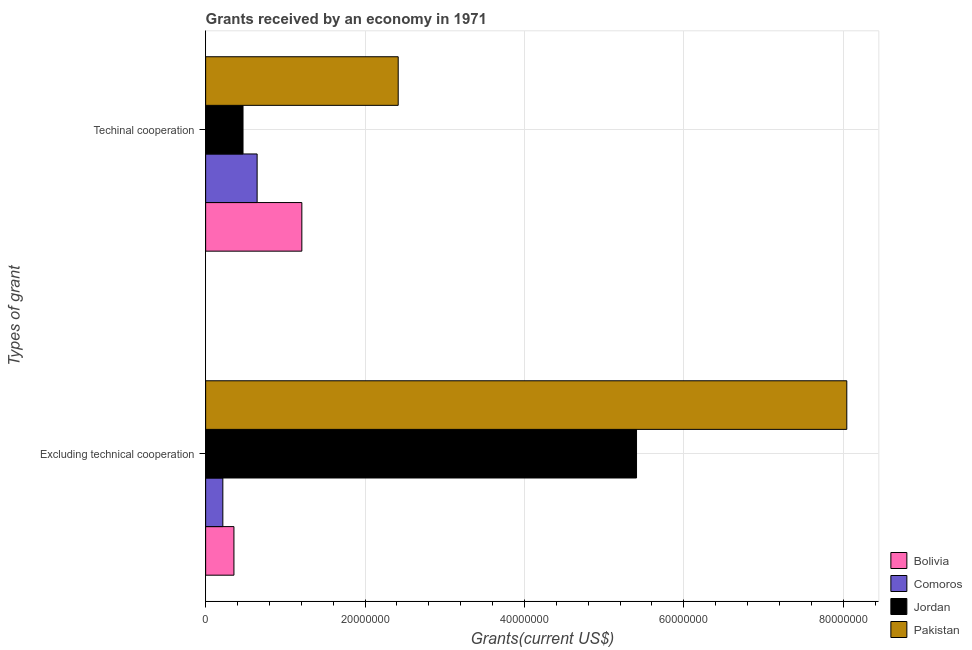How many bars are there on the 1st tick from the top?
Provide a succinct answer. 4. What is the label of the 1st group of bars from the top?
Provide a succinct answer. Techinal cooperation. What is the amount of grants received(including technical cooperation) in Comoros?
Provide a succinct answer. 6.46e+06. Across all countries, what is the maximum amount of grants received(including technical cooperation)?
Offer a terse response. 2.42e+07. Across all countries, what is the minimum amount of grants received(excluding technical cooperation)?
Provide a short and direct response. 2.16e+06. In which country was the amount of grants received(excluding technical cooperation) maximum?
Offer a very short reply. Pakistan. In which country was the amount of grants received(including technical cooperation) minimum?
Give a very brief answer. Jordan. What is the total amount of grants received(including technical cooperation) in the graph?
Offer a terse response. 4.74e+07. What is the difference between the amount of grants received(including technical cooperation) in Pakistan and that in Jordan?
Give a very brief answer. 1.95e+07. What is the difference between the amount of grants received(excluding technical cooperation) in Bolivia and the amount of grants received(including technical cooperation) in Comoros?
Offer a terse response. -2.91e+06. What is the average amount of grants received(including technical cooperation) per country?
Provide a short and direct response. 1.18e+07. What is the difference between the amount of grants received(excluding technical cooperation) and amount of grants received(including technical cooperation) in Jordan?
Your response must be concise. 4.94e+07. In how many countries, is the amount of grants received(excluding technical cooperation) greater than 68000000 US$?
Provide a succinct answer. 1. What is the ratio of the amount of grants received(including technical cooperation) in Pakistan to that in Jordan?
Provide a succinct answer. 5.15. Is the amount of grants received(including technical cooperation) in Comoros less than that in Pakistan?
Offer a very short reply. Yes. What does the 3rd bar from the top in Excluding technical cooperation represents?
Make the answer very short. Comoros. What does the 3rd bar from the bottom in Excluding technical cooperation represents?
Your answer should be compact. Jordan. How many bars are there?
Give a very brief answer. 8. What is the difference between two consecutive major ticks on the X-axis?
Ensure brevity in your answer.  2.00e+07. Where does the legend appear in the graph?
Your answer should be very brief. Bottom right. What is the title of the graph?
Your answer should be compact. Grants received by an economy in 1971. Does "Vietnam" appear as one of the legend labels in the graph?
Ensure brevity in your answer.  No. What is the label or title of the X-axis?
Offer a terse response. Grants(current US$). What is the label or title of the Y-axis?
Provide a succinct answer. Types of grant. What is the Grants(current US$) in Bolivia in Excluding technical cooperation?
Your answer should be compact. 3.55e+06. What is the Grants(current US$) in Comoros in Excluding technical cooperation?
Keep it short and to the point. 2.16e+06. What is the Grants(current US$) in Jordan in Excluding technical cooperation?
Ensure brevity in your answer.  5.41e+07. What is the Grants(current US$) of Pakistan in Excluding technical cooperation?
Provide a succinct answer. 8.04e+07. What is the Grants(current US$) of Bolivia in Techinal cooperation?
Offer a terse response. 1.21e+07. What is the Grants(current US$) of Comoros in Techinal cooperation?
Your response must be concise. 6.46e+06. What is the Grants(current US$) in Jordan in Techinal cooperation?
Give a very brief answer. 4.69e+06. What is the Grants(current US$) in Pakistan in Techinal cooperation?
Keep it short and to the point. 2.42e+07. Across all Types of grant, what is the maximum Grants(current US$) in Bolivia?
Make the answer very short. 1.21e+07. Across all Types of grant, what is the maximum Grants(current US$) of Comoros?
Your answer should be very brief. 6.46e+06. Across all Types of grant, what is the maximum Grants(current US$) in Jordan?
Offer a terse response. 5.41e+07. Across all Types of grant, what is the maximum Grants(current US$) of Pakistan?
Offer a terse response. 8.04e+07. Across all Types of grant, what is the minimum Grants(current US$) in Bolivia?
Keep it short and to the point. 3.55e+06. Across all Types of grant, what is the minimum Grants(current US$) of Comoros?
Offer a very short reply. 2.16e+06. Across all Types of grant, what is the minimum Grants(current US$) of Jordan?
Give a very brief answer. 4.69e+06. Across all Types of grant, what is the minimum Grants(current US$) in Pakistan?
Provide a succinct answer. 2.42e+07. What is the total Grants(current US$) of Bolivia in the graph?
Your answer should be compact. 1.56e+07. What is the total Grants(current US$) of Comoros in the graph?
Offer a very short reply. 8.62e+06. What is the total Grants(current US$) of Jordan in the graph?
Offer a terse response. 5.88e+07. What is the total Grants(current US$) of Pakistan in the graph?
Your answer should be very brief. 1.05e+08. What is the difference between the Grants(current US$) of Bolivia in Excluding technical cooperation and that in Techinal cooperation?
Keep it short and to the point. -8.52e+06. What is the difference between the Grants(current US$) in Comoros in Excluding technical cooperation and that in Techinal cooperation?
Make the answer very short. -4.30e+06. What is the difference between the Grants(current US$) in Jordan in Excluding technical cooperation and that in Techinal cooperation?
Provide a short and direct response. 4.94e+07. What is the difference between the Grants(current US$) in Pakistan in Excluding technical cooperation and that in Techinal cooperation?
Provide a succinct answer. 5.63e+07. What is the difference between the Grants(current US$) of Bolivia in Excluding technical cooperation and the Grants(current US$) of Comoros in Techinal cooperation?
Offer a terse response. -2.91e+06. What is the difference between the Grants(current US$) of Bolivia in Excluding technical cooperation and the Grants(current US$) of Jordan in Techinal cooperation?
Make the answer very short. -1.14e+06. What is the difference between the Grants(current US$) in Bolivia in Excluding technical cooperation and the Grants(current US$) in Pakistan in Techinal cooperation?
Give a very brief answer. -2.06e+07. What is the difference between the Grants(current US$) of Comoros in Excluding technical cooperation and the Grants(current US$) of Jordan in Techinal cooperation?
Provide a succinct answer. -2.53e+06. What is the difference between the Grants(current US$) of Comoros in Excluding technical cooperation and the Grants(current US$) of Pakistan in Techinal cooperation?
Offer a very short reply. -2.20e+07. What is the difference between the Grants(current US$) of Jordan in Excluding technical cooperation and the Grants(current US$) of Pakistan in Techinal cooperation?
Provide a succinct answer. 2.99e+07. What is the average Grants(current US$) in Bolivia per Types of grant?
Keep it short and to the point. 7.81e+06. What is the average Grants(current US$) in Comoros per Types of grant?
Offer a terse response. 4.31e+06. What is the average Grants(current US$) in Jordan per Types of grant?
Provide a short and direct response. 2.94e+07. What is the average Grants(current US$) of Pakistan per Types of grant?
Provide a short and direct response. 5.23e+07. What is the difference between the Grants(current US$) of Bolivia and Grants(current US$) of Comoros in Excluding technical cooperation?
Provide a short and direct response. 1.39e+06. What is the difference between the Grants(current US$) of Bolivia and Grants(current US$) of Jordan in Excluding technical cooperation?
Your answer should be very brief. -5.05e+07. What is the difference between the Grants(current US$) of Bolivia and Grants(current US$) of Pakistan in Excluding technical cooperation?
Your response must be concise. -7.69e+07. What is the difference between the Grants(current US$) in Comoros and Grants(current US$) in Jordan in Excluding technical cooperation?
Your response must be concise. -5.19e+07. What is the difference between the Grants(current US$) of Comoros and Grants(current US$) of Pakistan in Excluding technical cooperation?
Your response must be concise. -7.83e+07. What is the difference between the Grants(current US$) in Jordan and Grants(current US$) in Pakistan in Excluding technical cooperation?
Offer a terse response. -2.64e+07. What is the difference between the Grants(current US$) in Bolivia and Grants(current US$) in Comoros in Techinal cooperation?
Your answer should be very brief. 5.61e+06. What is the difference between the Grants(current US$) of Bolivia and Grants(current US$) of Jordan in Techinal cooperation?
Your answer should be very brief. 7.38e+06. What is the difference between the Grants(current US$) of Bolivia and Grants(current US$) of Pakistan in Techinal cooperation?
Provide a succinct answer. -1.21e+07. What is the difference between the Grants(current US$) in Comoros and Grants(current US$) in Jordan in Techinal cooperation?
Give a very brief answer. 1.77e+06. What is the difference between the Grants(current US$) in Comoros and Grants(current US$) in Pakistan in Techinal cooperation?
Keep it short and to the point. -1.77e+07. What is the difference between the Grants(current US$) in Jordan and Grants(current US$) in Pakistan in Techinal cooperation?
Ensure brevity in your answer.  -1.95e+07. What is the ratio of the Grants(current US$) in Bolivia in Excluding technical cooperation to that in Techinal cooperation?
Offer a terse response. 0.29. What is the ratio of the Grants(current US$) in Comoros in Excluding technical cooperation to that in Techinal cooperation?
Give a very brief answer. 0.33. What is the ratio of the Grants(current US$) in Jordan in Excluding technical cooperation to that in Techinal cooperation?
Keep it short and to the point. 11.53. What is the ratio of the Grants(current US$) of Pakistan in Excluding technical cooperation to that in Techinal cooperation?
Your response must be concise. 3.33. What is the difference between the highest and the second highest Grants(current US$) in Bolivia?
Make the answer very short. 8.52e+06. What is the difference between the highest and the second highest Grants(current US$) of Comoros?
Provide a short and direct response. 4.30e+06. What is the difference between the highest and the second highest Grants(current US$) in Jordan?
Offer a very short reply. 4.94e+07. What is the difference between the highest and the second highest Grants(current US$) in Pakistan?
Give a very brief answer. 5.63e+07. What is the difference between the highest and the lowest Grants(current US$) of Bolivia?
Give a very brief answer. 8.52e+06. What is the difference between the highest and the lowest Grants(current US$) in Comoros?
Your answer should be compact. 4.30e+06. What is the difference between the highest and the lowest Grants(current US$) in Jordan?
Offer a terse response. 4.94e+07. What is the difference between the highest and the lowest Grants(current US$) of Pakistan?
Make the answer very short. 5.63e+07. 